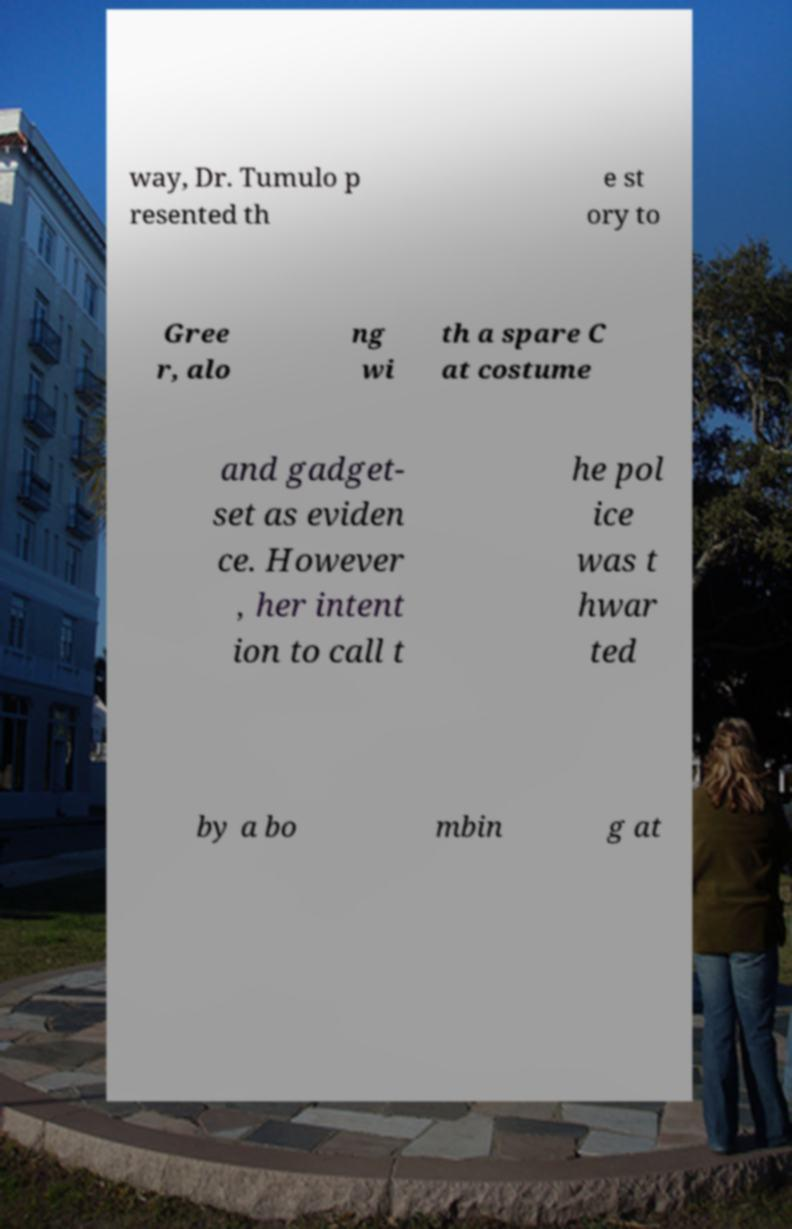Please read and relay the text visible in this image. What does it say? way, Dr. Tumulo p resented th e st ory to Gree r, alo ng wi th a spare C at costume and gadget- set as eviden ce. However , her intent ion to call t he pol ice was t hwar ted by a bo mbin g at 